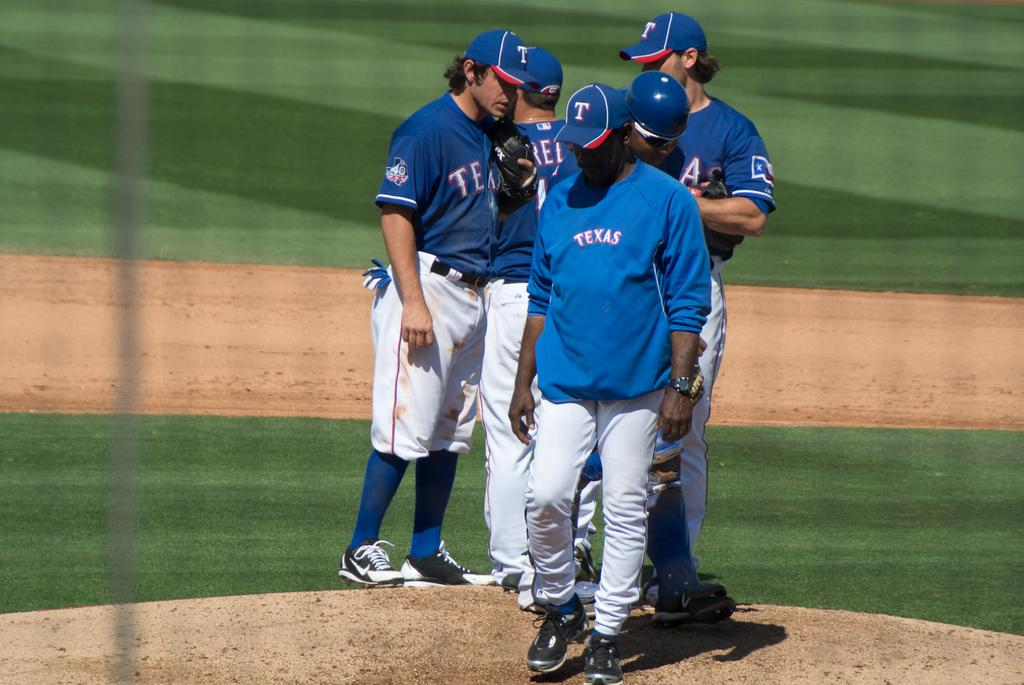<image>
Create a compact narrative representing the image presented. a man wearing a TEXAS jacket walks away from the players 